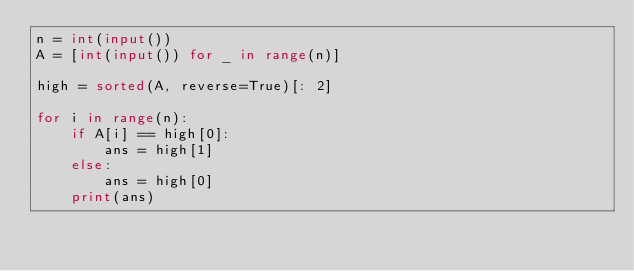<code> <loc_0><loc_0><loc_500><loc_500><_Python_>n = int(input())
A = [int(input()) for _ in range(n)]

high = sorted(A, reverse=True)[: 2]

for i in range(n):
    if A[i] == high[0]:
        ans = high[1]
    else:
        ans = high[0]
    print(ans)</code> 